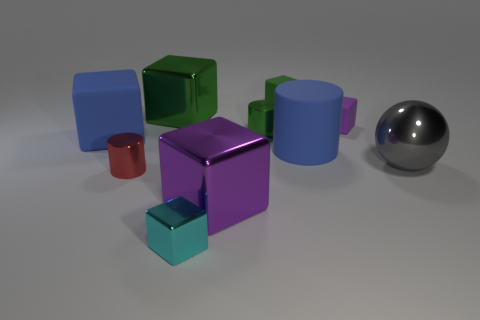What is the color of the rubber cylinder?
Offer a very short reply. Blue. The object that is both behind the tiny purple object and to the right of the tiny green cylinder is what color?
Offer a very short reply. Green. Is the gray thing made of the same material as the tiny cylinder that is in front of the big gray metallic ball?
Your answer should be compact. Yes. How big is the cylinder to the left of the large green metal block behind the gray ball?
Offer a very short reply. Small. Is there any other thing that has the same color as the matte cylinder?
Offer a terse response. Yes. Does the small block that is in front of the red shiny thing have the same material as the green cube that is right of the large green metallic cube?
Provide a succinct answer. No. What is the material of the block that is behind the tiny purple matte thing and to the left of the tiny cyan metallic cube?
Your answer should be compact. Metal. Does the green rubber thing have the same shape as the big metallic object behind the gray thing?
Offer a terse response. Yes. What is the object that is on the right side of the purple thing that is on the right side of the small shiny cylinder that is behind the red shiny cylinder made of?
Offer a terse response. Metal. What number of other objects are the same size as the red shiny cylinder?
Ensure brevity in your answer.  4. 